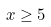Convert formula to latex. <formula><loc_0><loc_0><loc_500><loc_500>x \geq 5</formula> 